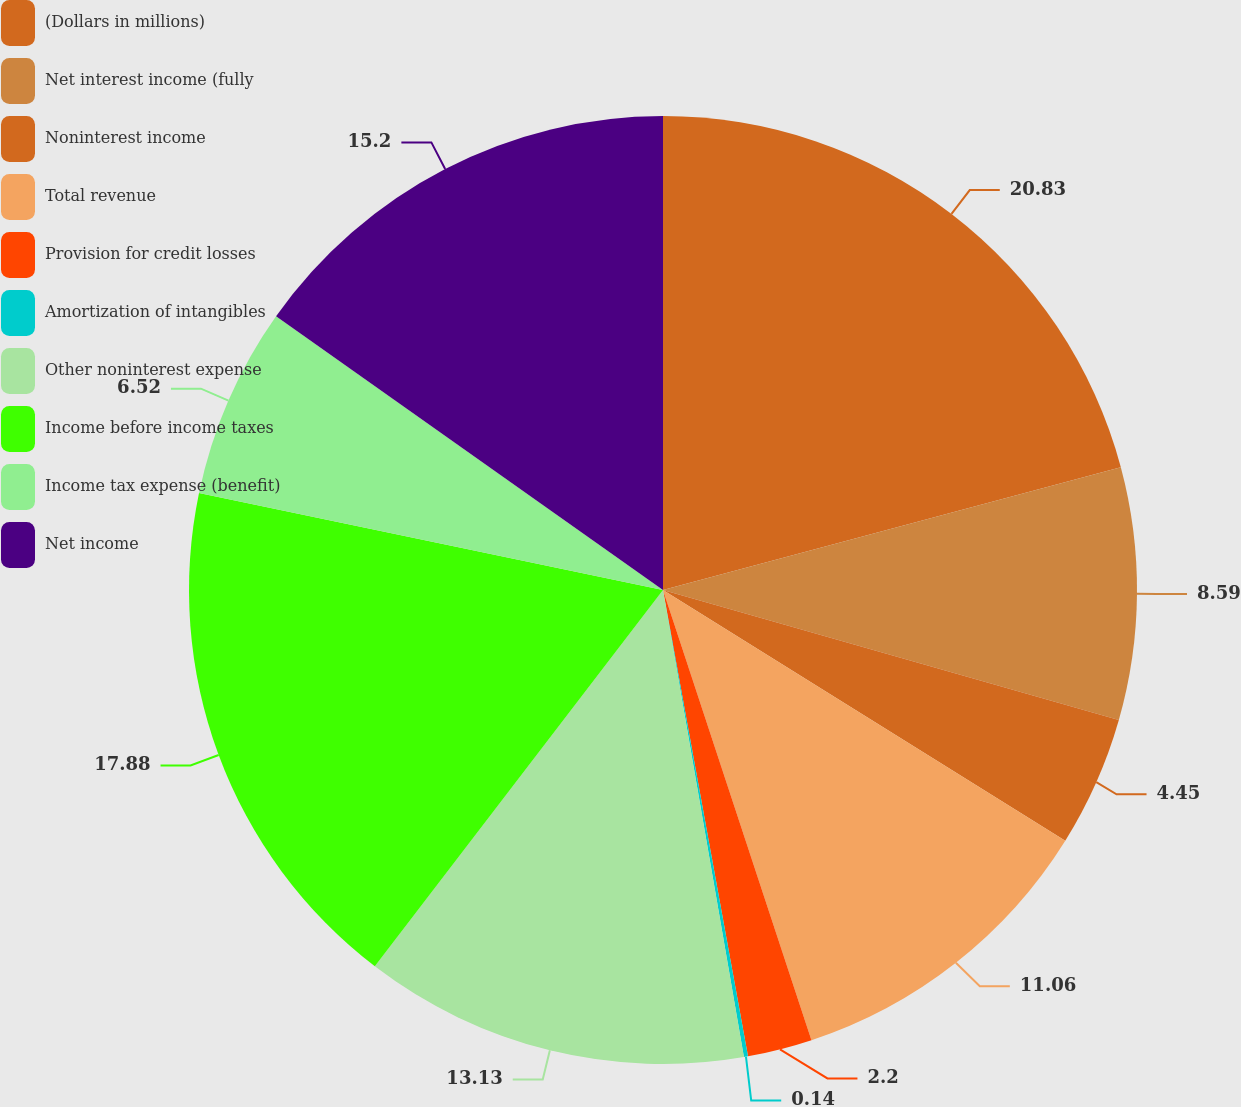Convert chart to OTSL. <chart><loc_0><loc_0><loc_500><loc_500><pie_chart><fcel>(Dollars in millions)<fcel>Net interest income (fully<fcel>Noninterest income<fcel>Total revenue<fcel>Provision for credit losses<fcel>Amortization of intangibles<fcel>Other noninterest expense<fcel>Income before income taxes<fcel>Income tax expense (benefit)<fcel>Net income<nl><fcel>20.83%<fcel>8.59%<fcel>4.45%<fcel>11.06%<fcel>2.2%<fcel>0.14%<fcel>13.13%<fcel>17.88%<fcel>6.52%<fcel>15.2%<nl></chart> 